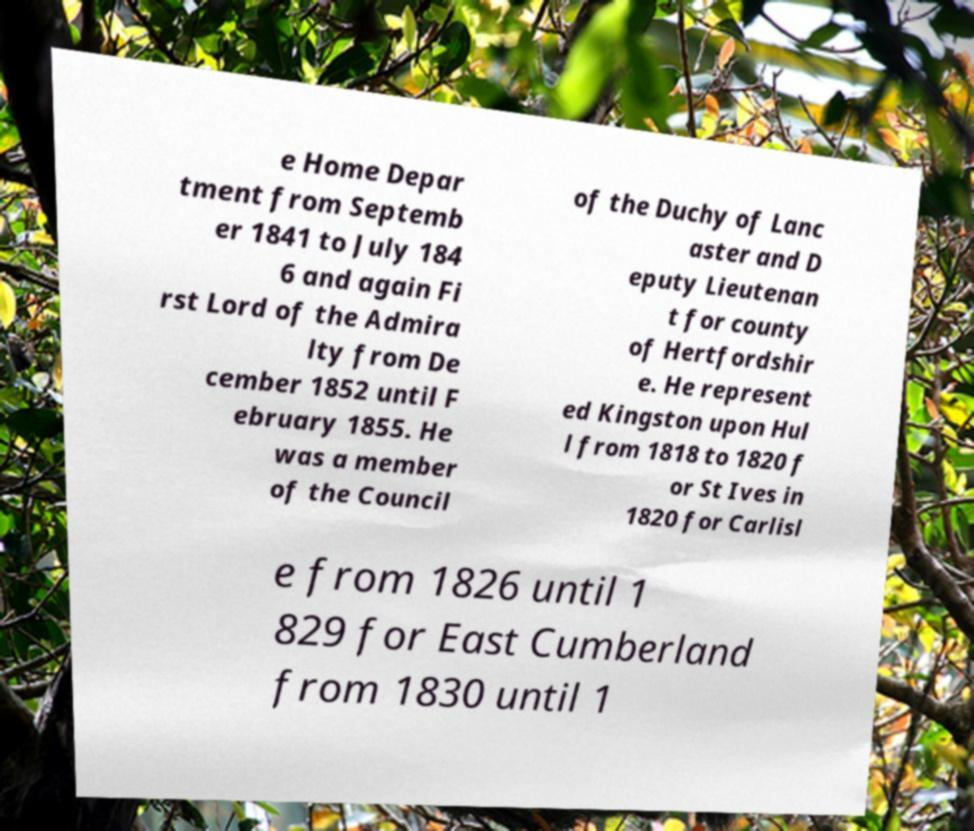Can you read and provide the text displayed in the image?This photo seems to have some interesting text. Can you extract and type it out for me? e Home Depar tment from Septemb er 1841 to July 184 6 and again Fi rst Lord of the Admira lty from De cember 1852 until F ebruary 1855. He was a member of the Council of the Duchy of Lanc aster and D eputy Lieutenan t for county of Hertfordshir e. He represent ed Kingston upon Hul l from 1818 to 1820 f or St Ives in 1820 for Carlisl e from 1826 until 1 829 for East Cumberland from 1830 until 1 